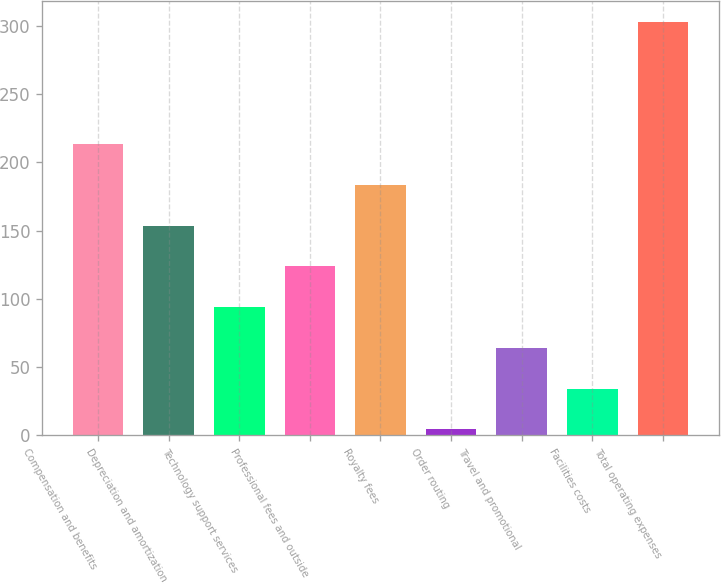<chart> <loc_0><loc_0><loc_500><loc_500><bar_chart><fcel>Compensation and benefits<fcel>Depreciation and amortization<fcel>Technology support services<fcel>Professional fees and outside<fcel>Royalty fees<fcel>Order routing<fcel>Travel and promotional<fcel>Facilities costs<fcel>Total operating expenses<nl><fcel>213.61<fcel>153.75<fcel>93.89<fcel>123.82<fcel>183.68<fcel>4.1<fcel>63.96<fcel>34.03<fcel>303.4<nl></chart> 